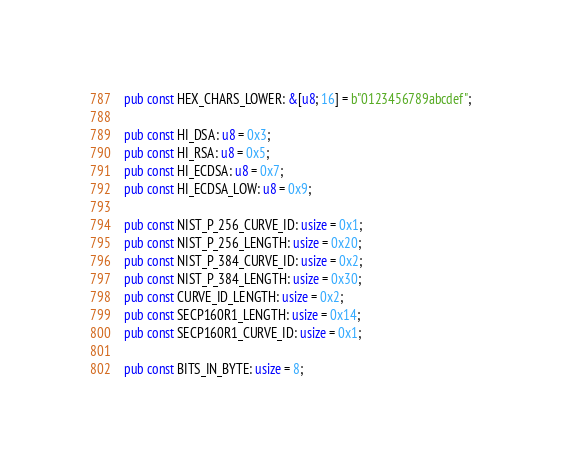<code> <loc_0><loc_0><loc_500><loc_500><_Rust_>
pub const HEX_CHARS_LOWER: &[u8; 16] = b"0123456789abcdef";

pub const HI_DSA: u8 = 0x3;
pub const HI_RSA: u8 = 0x5;
pub const HI_ECDSA: u8 = 0x7;
pub const HI_ECDSA_LOW: u8 = 0x9;

pub const NIST_P_256_CURVE_ID: usize = 0x1;
pub const NIST_P_256_LENGTH: usize = 0x20;
pub const NIST_P_384_CURVE_ID: usize = 0x2;
pub const NIST_P_384_LENGTH: usize = 0x30;
pub const CURVE_ID_LENGTH: usize = 0x2;
pub const SECP160R1_LENGTH: usize = 0x14;
pub const SECP160R1_CURVE_ID: usize = 0x1;

pub const BITS_IN_BYTE: usize = 8;
</code> 